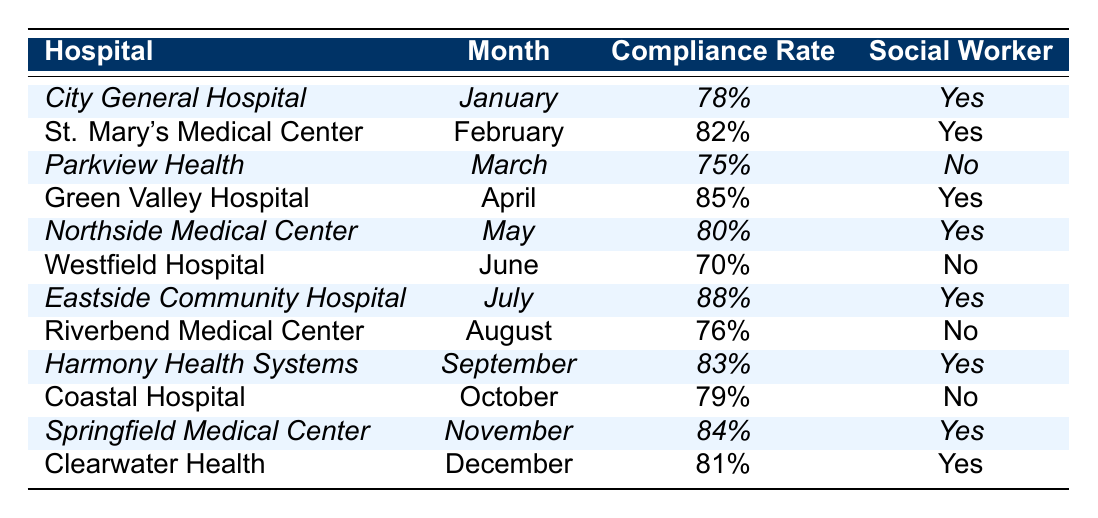What is the compliance rate for Eastside Community Hospital? The table shows the compliance rate specifically listed under Eastside Community Hospital, which is indicated as 88%.
Answer: 88% Which hospital had the lowest compliance rate in 2023? Looking at the compliance rates listed, Westfield Hospital has the lowest rate at 70%.
Answer: 70% How many hospitals had social worker involvement in their follow-up process? Six hospitals are marked with "Yes" under the social worker involvement column: City General Hospital, St. Mary's Medical Center, Green Valley Hospital, Northside Medical Center, Eastside Community Hospital, Harmony Health Systems, Springfield Medical Center, and Clearwater Health. That's a total of 8 hospitals.
Answer: 8 What is the average compliance rate for the hospitals with social worker involvement? First, identify the compliance rates for the hospitals with social worker involvement: 78%, 82%, 85%, 80%, 88%, 83%, 84%, 81%. The sum of these rates is 678%. There are 8 hospitals, so the average is 678% / 8 = 84.75%.
Answer: 84.75% Did any hospital have a compliance rate of 75%? Parkview Health is listed in the table with a compliance rate of 75%, confirming that this is true.
Answer: Yes Which month had the highest compliance rate and which hospital was it? The highest compliance rate is 88%, which occurred in July for Eastside Community Hospital.
Answer: July, Eastside Community Hospital Was there any month where a hospital without social worker involvement had a compliance rate above 75%? The only hospital without social worker involvement listed is Westfield Hospital at 70%, Riverbend Medical Center at 76%, and Coastal Hospital at 79%. Riverbend Medical Center does exceed 75%, making this statement true.
Answer: Yes If we compare the compliance rates for the months of January to April, what is the sum of those rates? The rates for January (78%), February (82%), March (75%), and April (85%) add up: 78 + 82 + 75 + 85 = 320.
Answer: 320 